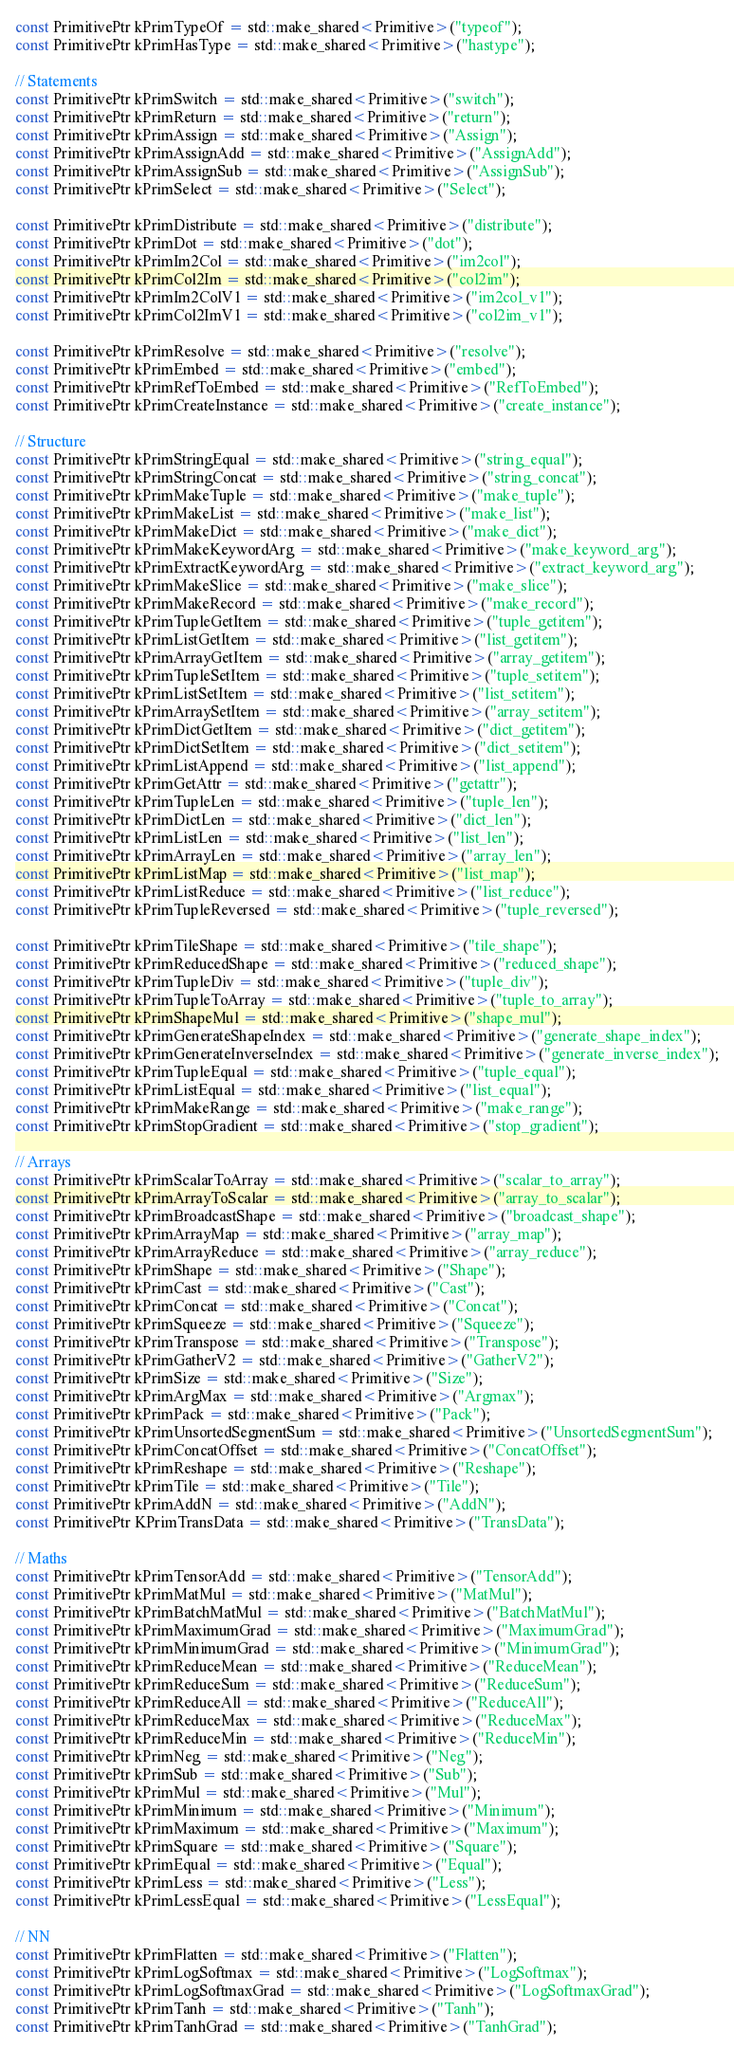<code> <loc_0><loc_0><loc_500><loc_500><_C++_>const PrimitivePtr kPrimTypeOf = std::make_shared<Primitive>("typeof");
const PrimitivePtr kPrimHasType = std::make_shared<Primitive>("hastype");

// Statements
const PrimitivePtr kPrimSwitch = std::make_shared<Primitive>("switch");
const PrimitivePtr kPrimReturn = std::make_shared<Primitive>("return");
const PrimitivePtr kPrimAssign = std::make_shared<Primitive>("Assign");
const PrimitivePtr kPrimAssignAdd = std::make_shared<Primitive>("AssignAdd");
const PrimitivePtr kPrimAssignSub = std::make_shared<Primitive>("AssignSub");
const PrimitivePtr kPrimSelect = std::make_shared<Primitive>("Select");

const PrimitivePtr kPrimDistribute = std::make_shared<Primitive>("distribute");
const PrimitivePtr kPrimDot = std::make_shared<Primitive>("dot");
const PrimitivePtr kPrimIm2Col = std::make_shared<Primitive>("im2col");
const PrimitivePtr kPrimCol2Im = std::make_shared<Primitive>("col2im");
const PrimitivePtr kPrimIm2ColV1 = std::make_shared<Primitive>("im2col_v1");
const PrimitivePtr kPrimCol2ImV1 = std::make_shared<Primitive>("col2im_v1");

const PrimitivePtr kPrimResolve = std::make_shared<Primitive>("resolve");
const PrimitivePtr kPrimEmbed = std::make_shared<Primitive>("embed");
const PrimitivePtr kPrimRefToEmbed = std::make_shared<Primitive>("RefToEmbed");
const PrimitivePtr kPrimCreateInstance = std::make_shared<Primitive>("create_instance");

// Structure
const PrimitivePtr kPrimStringEqual = std::make_shared<Primitive>("string_equal");
const PrimitivePtr kPrimStringConcat = std::make_shared<Primitive>("string_concat");
const PrimitivePtr kPrimMakeTuple = std::make_shared<Primitive>("make_tuple");
const PrimitivePtr kPrimMakeList = std::make_shared<Primitive>("make_list");
const PrimitivePtr kPrimMakeDict = std::make_shared<Primitive>("make_dict");
const PrimitivePtr kPrimMakeKeywordArg = std::make_shared<Primitive>("make_keyword_arg");
const PrimitivePtr kPrimExtractKeywordArg = std::make_shared<Primitive>("extract_keyword_arg");
const PrimitivePtr kPrimMakeSlice = std::make_shared<Primitive>("make_slice");
const PrimitivePtr kPrimMakeRecord = std::make_shared<Primitive>("make_record");
const PrimitivePtr kPrimTupleGetItem = std::make_shared<Primitive>("tuple_getitem");
const PrimitivePtr kPrimListGetItem = std::make_shared<Primitive>("list_getitem");
const PrimitivePtr kPrimArrayGetItem = std::make_shared<Primitive>("array_getitem");
const PrimitivePtr kPrimTupleSetItem = std::make_shared<Primitive>("tuple_setitem");
const PrimitivePtr kPrimListSetItem = std::make_shared<Primitive>("list_setitem");
const PrimitivePtr kPrimArraySetItem = std::make_shared<Primitive>("array_setitem");
const PrimitivePtr kPrimDictGetItem = std::make_shared<Primitive>("dict_getitem");
const PrimitivePtr kPrimDictSetItem = std::make_shared<Primitive>("dict_setitem");
const PrimitivePtr kPrimListAppend = std::make_shared<Primitive>("list_append");
const PrimitivePtr kPrimGetAttr = std::make_shared<Primitive>("getattr");
const PrimitivePtr kPrimTupleLen = std::make_shared<Primitive>("tuple_len");
const PrimitivePtr kPrimDictLen = std::make_shared<Primitive>("dict_len");
const PrimitivePtr kPrimListLen = std::make_shared<Primitive>("list_len");
const PrimitivePtr kPrimArrayLen = std::make_shared<Primitive>("array_len");
const PrimitivePtr kPrimListMap = std::make_shared<Primitive>("list_map");
const PrimitivePtr kPrimListReduce = std::make_shared<Primitive>("list_reduce");
const PrimitivePtr kPrimTupleReversed = std::make_shared<Primitive>("tuple_reversed");

const PrimitivePtr kPrimTileShape = std::make_shared<Primitive>("tile_shape");
const PrimitivePtr kPrimReducedShape = std::make_shared<Primitive>("reduced_shape");
const PrimitivePtr kPrimTupleDiv = std::make_shared<Primitive>("tuple_div");
const PrimitivePtr kPrimTupleToArray = std::make_shared<Primitive>("tuple_to_array");
const PrimitivePtr kPrimShapeMul = std::make_shared<Primitive>("shape_mul");
const PrimitivePtr kPrimGenerateShapeIndex = std::make_shared<Primitive>("generate_shape_index");
const PrimitivePtr kPrimGenerateInverseIndex = std::make_shared<Primitive>("generate_inverse_index");
const PrimitivePtr kPrimTupleEqual = std::make_shared<Primitive>("tuple_equal");
const PrimitivePtr kPrimListEqual = std::make_shared<Primitive>("list_equal");
const PrimitivePtr kPrimMakeRange = std::make_shared<Primitive>("make_range");
const PrimitivePtr kPrimStopGradient = std::make_shared<Primitive>("stop_gradient");

// Arrays
const PrimitivePtr kPrimScalarToArray = std::make_shared<Primitive>("scalar_to_array");
const PrimitivePtr kPrimArrayToScalar = std::make_shared<Primitive>("array_to_scalar");
const PrimitivePtr kPrimBroadcastShape = std::make_shared<Primitive>("broadcast_shape");
const PrimitivePtr kPrimArrayMap = std::make_shared<Primitive>("array_map");
const PrimitivePtr kPrimArrayReduce = std::make_shared<Primitive>("array_reduce");
const PrimitivePtr kPrimShape = std::make_shared<Primitive>("Shape");
const PrimitivePtr kPrimCast = std::make_shared<Primitive>("Cast");
const PrimitivePtr kPrimConcat = std::make_shared<Primitive>("Concat");
const PrimitivePtr kPrimSqueeze = std::make_shared<Primitive>("Squeeze");
const PrimitivePtr kPrimTranspose = std::make_shared<Primitive>("Transpose");
const PrimitivePtr kPrimGatherV2 = std::make_shared<Primitive>("GatherV2");
const PrimitivePtr kPrimSize = std::make_shared<Primitive>("Size");
const PrimitivePtr kPrimArgMax = std::make_shared<Primitive>("Argmax");
const PrimitivePtr kPrimPack = std::make_shared<Primitive>("Pack");
const PrimitivePtr kPrimUnsortedSegmentSum = std::make_shared<Primitive>("UnsortedSegmentSum");
const PrimitivePtr kPrimConcatOffset = std::make_shared<Primitive>("ConcatOffset");
const PrimitivePtr kPrimReshape = std::make_shared<Primitive>("Reshape");
const PrimitivePtr kPrimTile = std::make_shared<Primitive>("Tile");
const PrimitivePtr kPrimAddN = std::make_shared<Primitive>("AddN");
const PrimitivePtr KPrimTransData = std::make_shared<Primitive>("TransData");

// Maths
const PrimitivePtr kPrimTensorAdd = std::make_shared<Primitive>("TensorAdd");
const PrimitivePtr kPrimMatMul = std::make_shared<Primitive>("MatMul");
const PrimitivePtr kPrimBatchMatMul = std::make_shared<Primitive>("BatchMatMul");
const PrimitivePtr kPrimMaximumGrad = std::make_shared<Primitive>("MaximumGrad");
const PrimitivePtr kPrimMinimumGrad = std::make_shared<Primitive>("MinimumGrad");
const PrimitivePtr kPrimReduceMean = std::make_shared<Primitive>("ReduceMean");
const PrimitivePtr kPrimReduceSum = std::make_shared<Primitive>("ReduceSum");
const PrimitivePtr kPrimReduceAll = std::make_shared<Primitive>("ReduceAll");
const PrimitivePtr kPrimReduceMax = std::make_shared<Primitive>("ReduceMax");
const PrimitivePtr kPrimReduceMin = std::make_shared<Primitive>("ReduceMin");
const PrimitivePtr kPrimNeg = std::make_shared<Primitive>("Neg");
const PrimitivePtr kPrimSub = std::make_shared<Primitive>("Sub");
const PrimitivePtr kPrimMul = std::make_shared<Primitive>("Mul");
const PrimitivePtr kPrimMinimum = std::make_shared<Primitive>("Minimum");
const PrimitivePtr kPrimMaximum = std::make_shared<Primitive>("Maximum");
const PrimitivePtr kPrimSquare = std::make_shared<Primitive>("Square");
const PrimitivePtr kPrimEqual = std::make_shared<Primitive>("Equal");
const PrimitivePtr kPrimLess = std::make_shared<Primitive>("Less");
const PrimitivePtr kPrimLessEqual = std::make_shared<Primitive>("LessEqual");

// NN
const PrimitivePtr kPrimFlatten = std::make_shared<Primitive>("Flatten");
const PrimitivePtr kPrimLogSoftmax = std::make_shared<Primitive>("LogSoftmax");
const PrimitivePtr kPrimLogSoftmaxGrad = std::make_shared<Primitive>("LogSoftmaxGrad");
const PrimitivePtr kPrimTanh = std::make_shared<Primitive>("Tanh");
const PrimitivePtr kPrimTanhGrad = std::make_shared<Primitive>("TanhGrad");</code> 